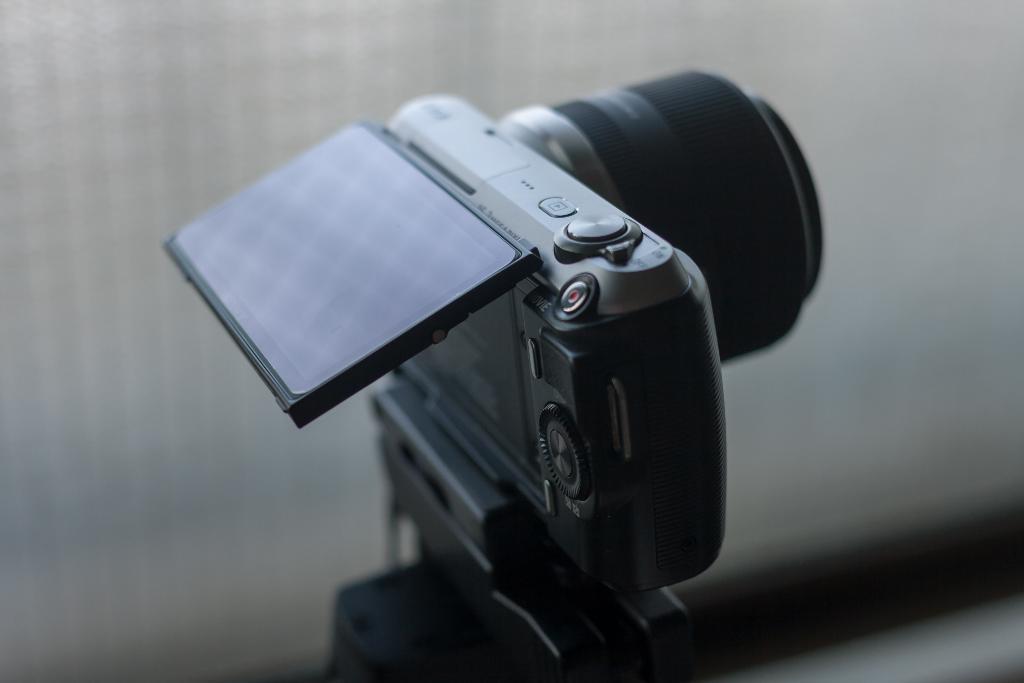Can you describe this image briefly? In this picture we can see a camera and in the background we can see it is blurry. 